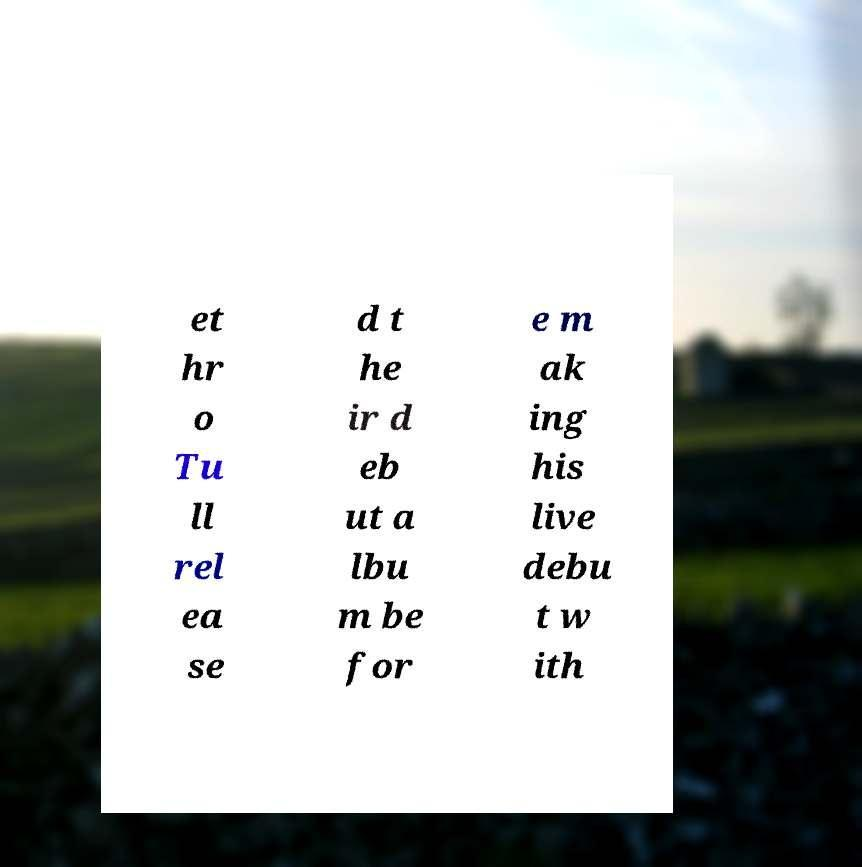Please read and relay the text visible in this image. What does it say? et hr o Tu ll rel ea se d t he ir d eb ut a lbu m be for e m ak ing his live debu t w ith 